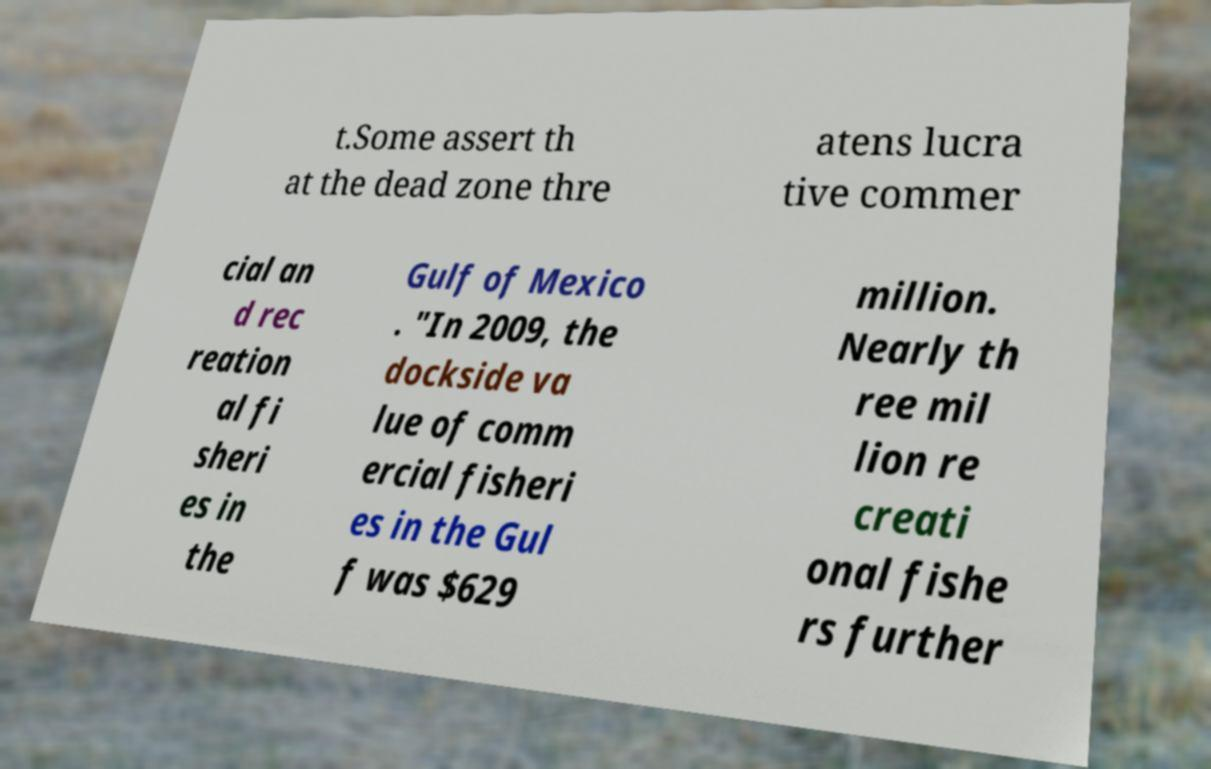There's text embedded in this image that I need extracted. Can you transcribe it verbatim? t.Some assert th at the dead zone thre atens lucra tive commer cial an d rec reation al fi sheri es in the Gulf of Mexico . "In 2009, the dockside va lue of comm ercial fisheri es in the Gul f was $629 million. Nearly th ree mil lion re creati onal fishe rs further 